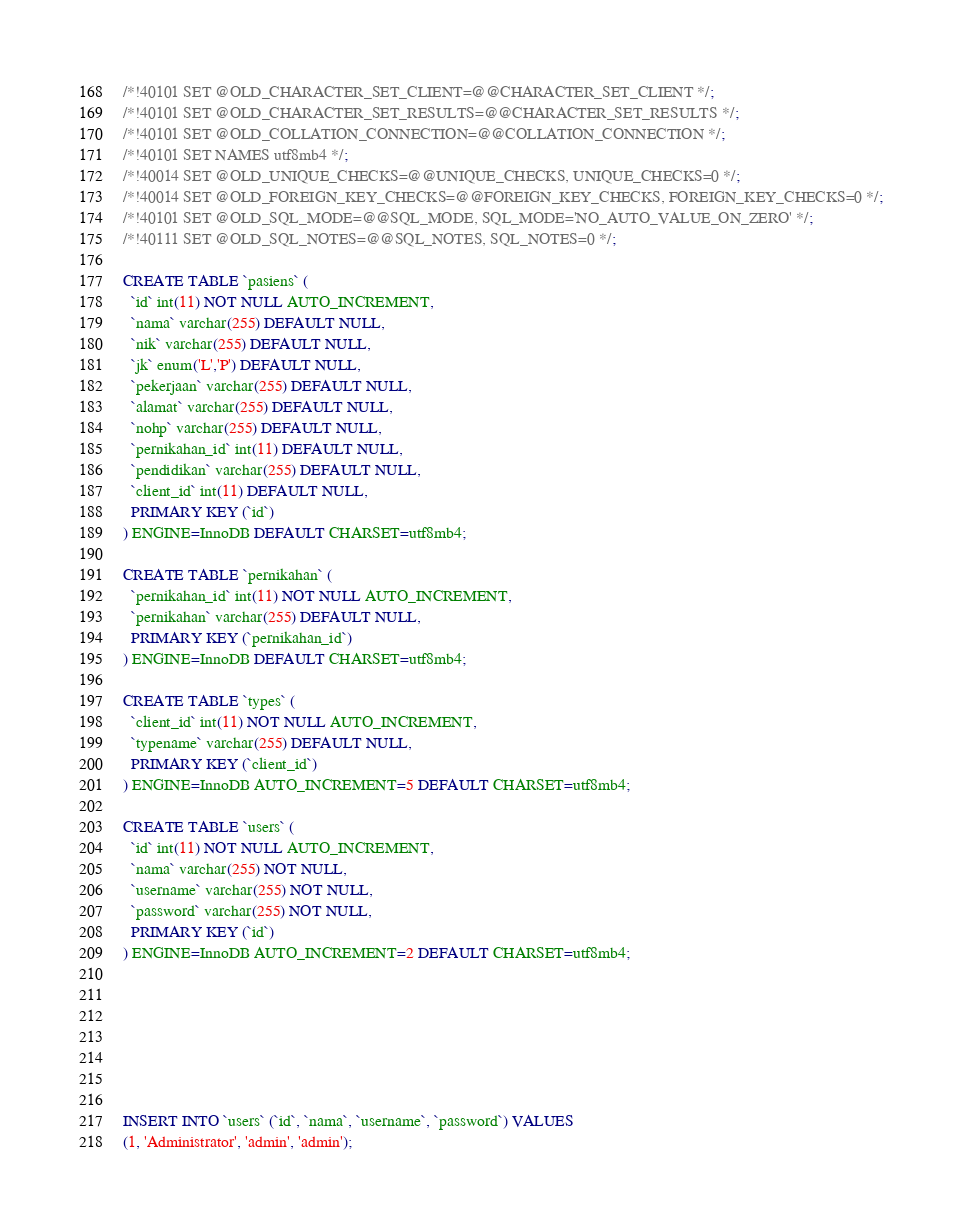Convert code to text. <code><loc_0><loc_0><loc_500><loc_500><_SQL_>/*!40101 SET @OLD_CHARACTER_SET_CLIENT=@@CHARACTER_SET_CLIENT */;
/*!40101 SET @OLD_CHARACTER_SET_RESULTS=@@CHARACTER_SET_RESULTS */;
/*!40101 SET @OLD_COLLATION_CONNECTION=@@COLLATION_CONNECTION */;
/*!40101 SET NAMES utf8mb4 */;
/*!40014 SET @OLD_UNIQUE_CHECKS=@@UNIQUE_CHECKS, UNIQUE_CHECKS=0 */;
/*!40014 SET @OLD_FOREIGN_KEY_CHECKS=@@FOREIGN_KEY_CHECKS, FOREIGN_KEY_CHECKS=0 */;
/*!40101 SET @OLD_SQL_MODE=@@SQL_MODE, SQL_MODE='NO_AUTO_VALUE_ON_ZERO' */;
/*!40111 SET @OLD_SQL_NOTES=@@SQL_NOTES, SQL_NOTES=0 */;

CREATE TABLE `pasiens` (
  `id` int(11) NOT NULL AUTO_INCREMENT,
  `nama` varchar(255) DEFAULT NULL,
  `nik` varchar(255) DEFAULT NULL,
  `jk` enum('L','P') DEFAULT NULL,
  `pekerjaan` varchar(255) DEFAULT NULL,
  `alamat` varchar(255) DEFAULT NULL,
  `nohp` varchar(255) DEFAULT NULL,
  `pernikahan_id` int(11) DEFAULT NULL,
  `pendidikan` varchar(255) DEFAULT NULL,
  `client_id` int(11) DEFAULT NULL,
  PRIMARY KEY (`id`)
) ENGINE=InnoDB DEFAULT CHARSET=utf8mb4;

CREATE TABLE `pernikahan` (
  `pernikahan_id` int(11) NOT NULL AUTO_INCREMENT,
  `pernikahan` varchar(255) DEFAULT NULL,
  PRIMARY KEY (`pernikahan_id`)
) ENGINE=InnoDB DEFAULT CHARSET=utf8mb4;

CREATE TABLE `types` (
  `client_id` int(11) NOT NULL AUTO_INCREMENT,
  `typename` varchar(255) DEFAULT NULL,
  PRIMARY KEY (`client_id`)
) ENGINE=InnoDB AUTO_INCREMENT=5 DEFAULT CHARSET=utf8mb4;

CREATE TABLE `users` (
  `id` int(11) NOT NULL AUTO_INCREMENT,
  `nama` varchar(255) NOT NULL,
  `username` varchar(255) NOT NULL,
  `password` varchar(255) NOT NULL,
  PRIMARY KEY (`id`)
) ENGINE=InnoDB AUTO_INCREMENT=2 DEFAULT CHARSET=utf8mb4;







INSERT INTO `users` (`id`, `nama`, `username`, `password`) VALUES
(1, 'Administrator', 'admin', 'admin');


</code> 